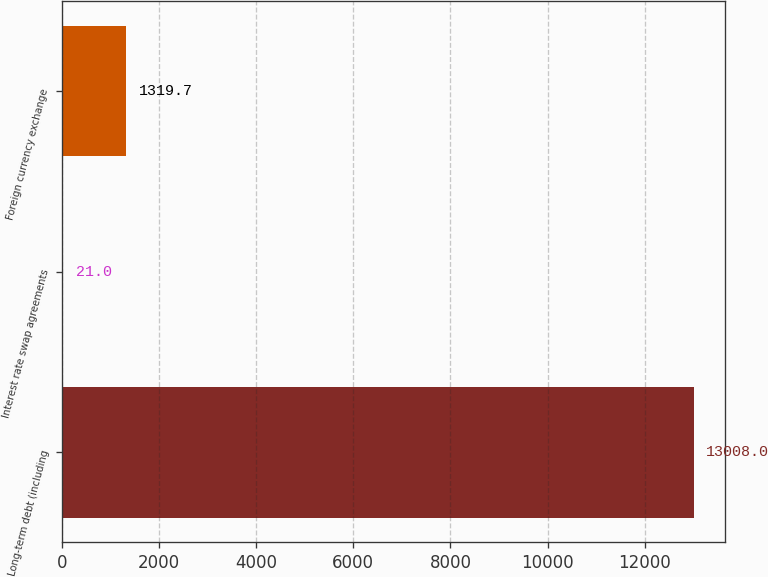Convert chart. <chart><loc_0><loc_0><loc_500><loc_500><bar_chart><fcel>Long-term debt (including<fcel>Interest rate swap agreements<fcel>Foreign currency exchange<nl><fcel>13008<fcel>21<fcel>1319.7<nl></chart> 